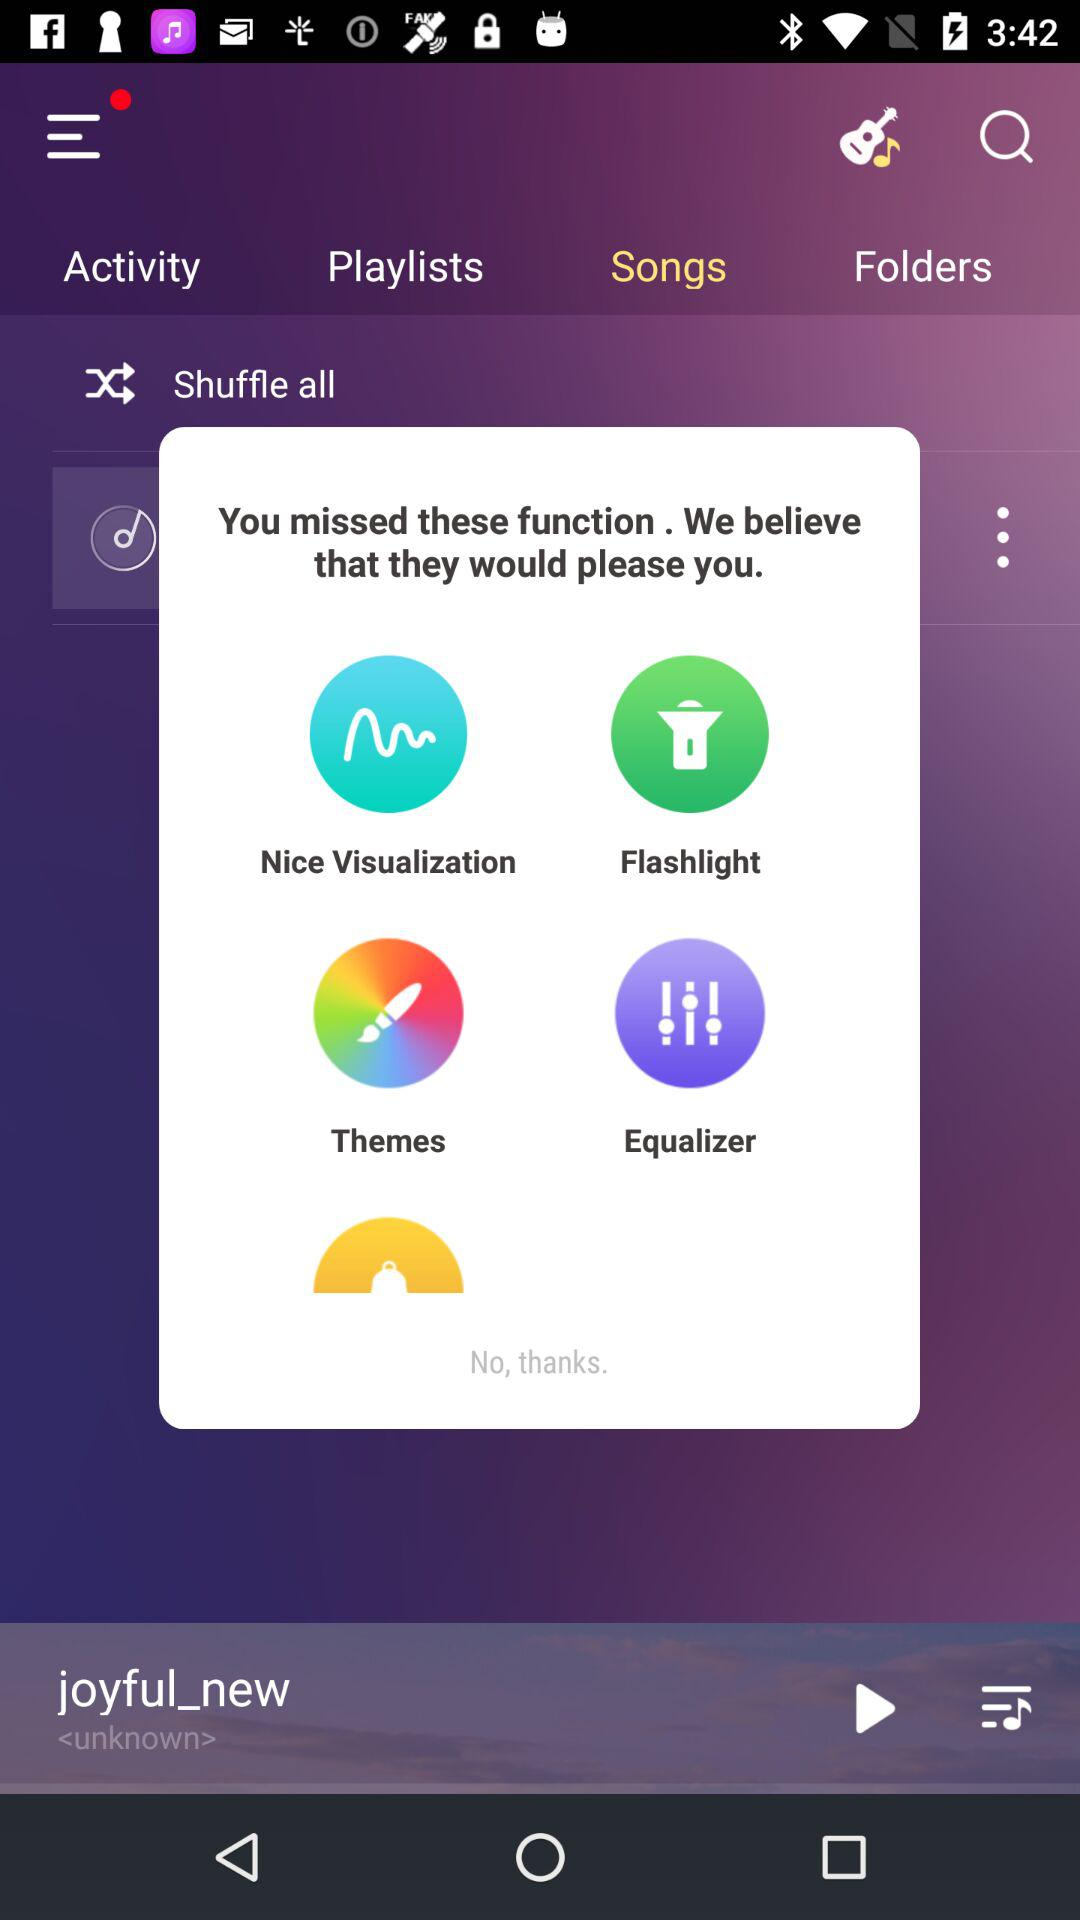What is the name of the currently playing song? The currently playing song is "joyful_new". 